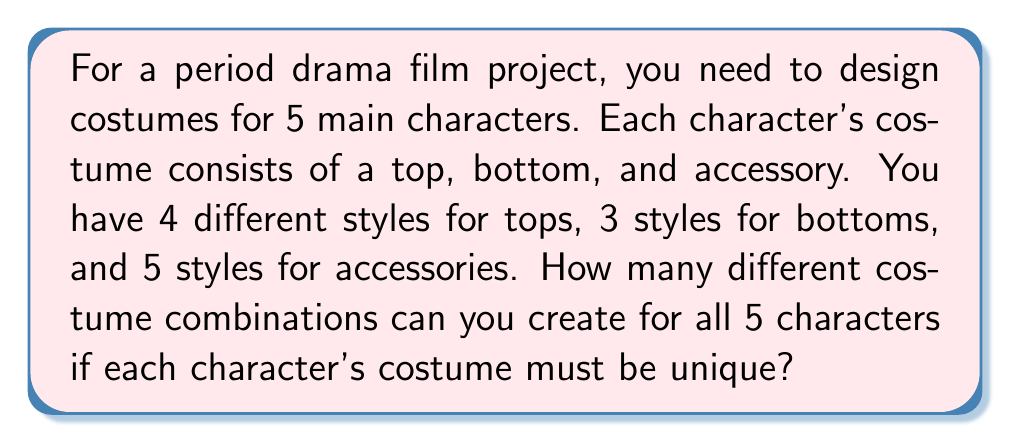Provide a solution to this math problem. Let's approach this step-by-step:

1) First, let's calculate the number of possible costume combinations for a single character:
   - There are 4 choices for tops, 3 for bottoms, and 5 for accessories
   - For one character: $4 \times 3 \times 5 = 60$ combinations

2) Now, we need to choose unique combinations for 5 characters. This is a permutation problem without repetition.

3) For the first character, we have all 60 choices available.

4) For the second character, we have 59 choices (as one combination is used).

5) For the third character, we have 58 choices, and so on.

6) This gives us the following calculation:
   $60 \times 59 \times 58 \times 57 \times 56$

7) In combinatorics, this is denoted as:
   $P(60, 5) = \frac{60!}{(60-5)!} = \frac{60!}{55!}$

8) Calculating this:
   $$\frac{60!}{55!} = 60 \times 59 \times 58 \times 57 \times 56 = 600,805,296$$

Therefore, there are 600,805,296 different ways to create unique costume combinations for all 5 characters.
Answer: 600,805,296 